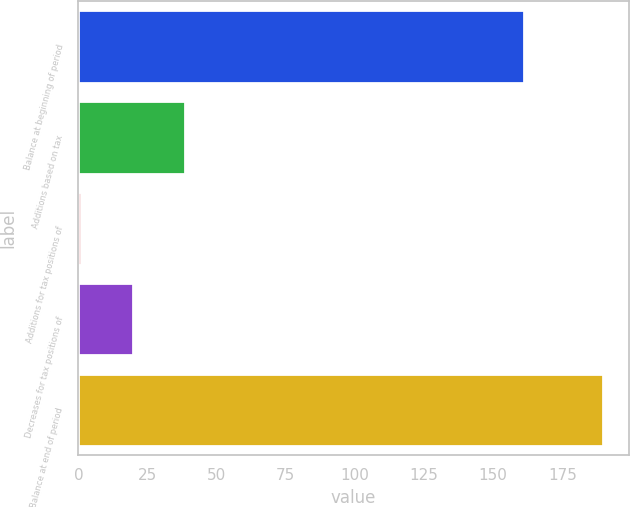Convert chart to OTSL. <chart><loc_0><loc_0><loc_500><loc_500><bar_chart><fcel>Balance at beginning of period<fcel>Additions based on tax<fcel>Additions for tax positions of<fcel>Decreases for tax positions of<fcel>Balance at end of period<nl><fcel>161<fcel>38.72<fcel>1<fcel>19.86<fcel>189.6<nl></chart> 